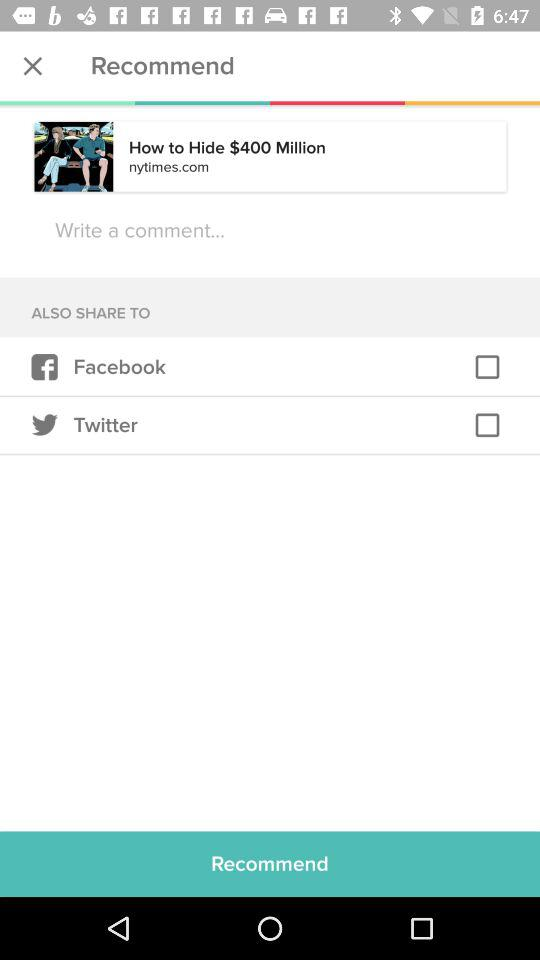Through what app can I share? You can share it through "Facebook" and "Twitter". 